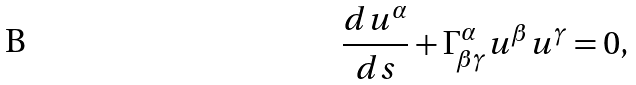<formula> <loc_0><loc_0><loc_500><loc_500>\frac { d u ^ { \alpha } } { d s } + \Gamma _ { \beta \gamma } ^ { \alpha } u ^ { \beta } u ^ { \gamma } = 0 ,</formula> 